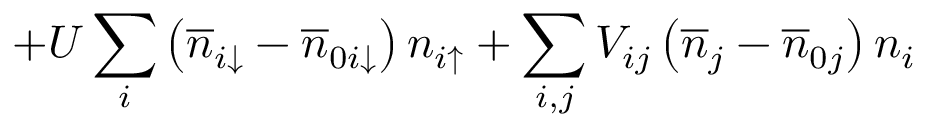<formula> <loc_0><loc_0><loc_500><loc_500>+ U \sum _ { i } \left ( \overline { n } _ { i \downarrow } - \overline { n } _ { 0 i \downarrow } \right ) n _ { i \uparrow } + \sum _ { i , j } V _ { i j } \left ( \overline { n } _ { j } - \overline { n } _ { 0 j } \right ) n _ { i }</formula> 